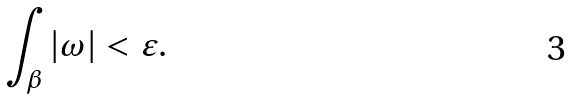<formula> <loc_0><loc_0><loc_500><loc_500>\int _ { \beta } | \omega | < \varepsilon .</formula> 